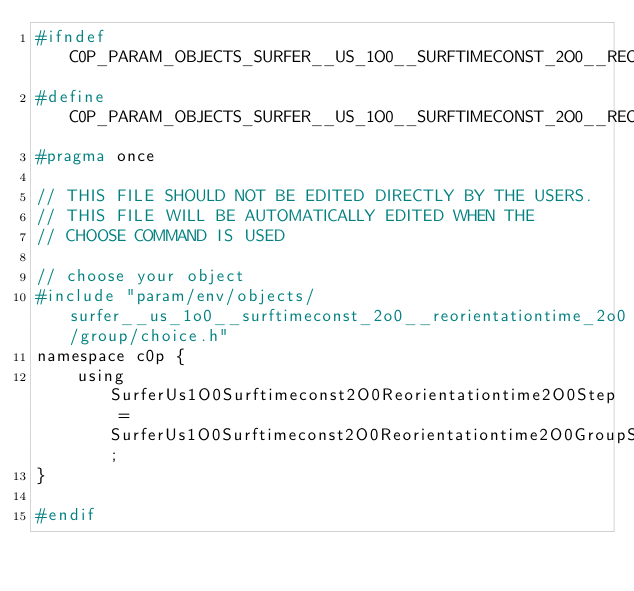<code> <loc_0><loc_0><loc_500><loc_500><_C_>#ifndef C0P_PARAM_OBJECTS_SURFER__US_1O0__SURFTIMECONST_2O0__REORIENTATIONTIME_2O0_CHOICE_H
#define C0P_PARAM_OBJECTS_SURFER__US_1O0__SURFTIMECONST_2O0__REORIENTATIONTIME_2O0_CHOICE_H
#pragma once

// THIS FILE SHOULD NOT BE EDITED DIRECTLY BY THE USERS.
// THIS FILE WILL BE AUTOMATICALLY EDITED WHEN THE
// CHOOSE COMMAND IS USED

// choose your object
#include "param/env/objects/surfer__us_1o0__surftimeconst_2o0__reorientationtime_2o0/group/choice.h"
namespace c0p {
    using SurferUs1O0Surftimeconst2O0Reorientationtime2O0Step = SurferUs1O0Surftimeconst2O0Reorientationtime2O0GroupStep;
}

#endif
</code> 